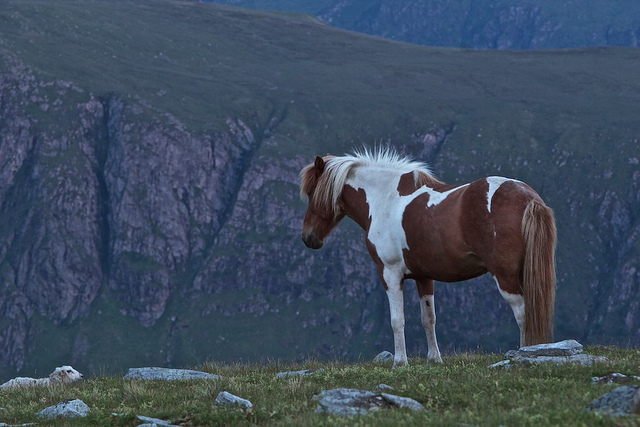<image>What is the possible danger to the horse? The possible danger to the horse might be falling or falling off the cliff. However, there may also be no danger. It's ambiguous. What is the possible danger to the horse? I don't know what the possible danger to the horse is. It can be falling off a cliff or nothing. 